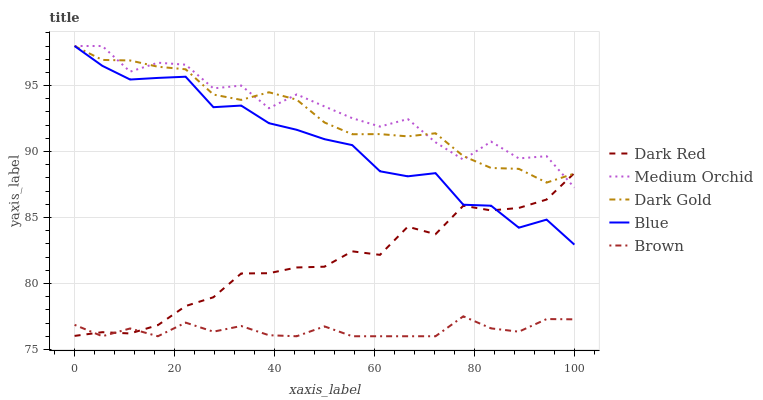Does Brown have the minimum area under the curve?
Answer yes or no. Yes. Does Medium Orchid have the maximum area under the curve?
Answer yes or no. Yes. Does Dark Red have the minimum area under the curve?
Answer yes or no. No. Does Dark Red have the maximum area under the curve?
Answer yes or no. No. Is Dark Gold the smoothest?
Answer yes or no. Yes. Is Medium Orchid the roughest?
Answer yes or no. Yes. Is Dark Red the smoothest?
Answer yes or no. No. Is Dark Red the roughest?
Answer yes or no. No. Does Brown have the lowest value?
Answer yes or no. Yes. Does Dark Red have the lowest value?
Answer yes or no. No. Does Dark Gold have the highest value?
Answer yes or no. Yes. Does Dark Red have the highest value?
Answer yes or no. No. Is Brown less than Dark Gold?
Answer yes or no. Yes. Is Blue greater than Brown?
Answer yes or no. Yes. Does Dark Red intersect Dark Gold?
Answer yes or no. Yes. Is Dark Red less than Dark Gold?
Answer yes or no. No. Is Dark Red greater than Dark Gold?
Answer yes or no. No. Does Brown intersect Dark Gold?
Answer yes or no. No. 